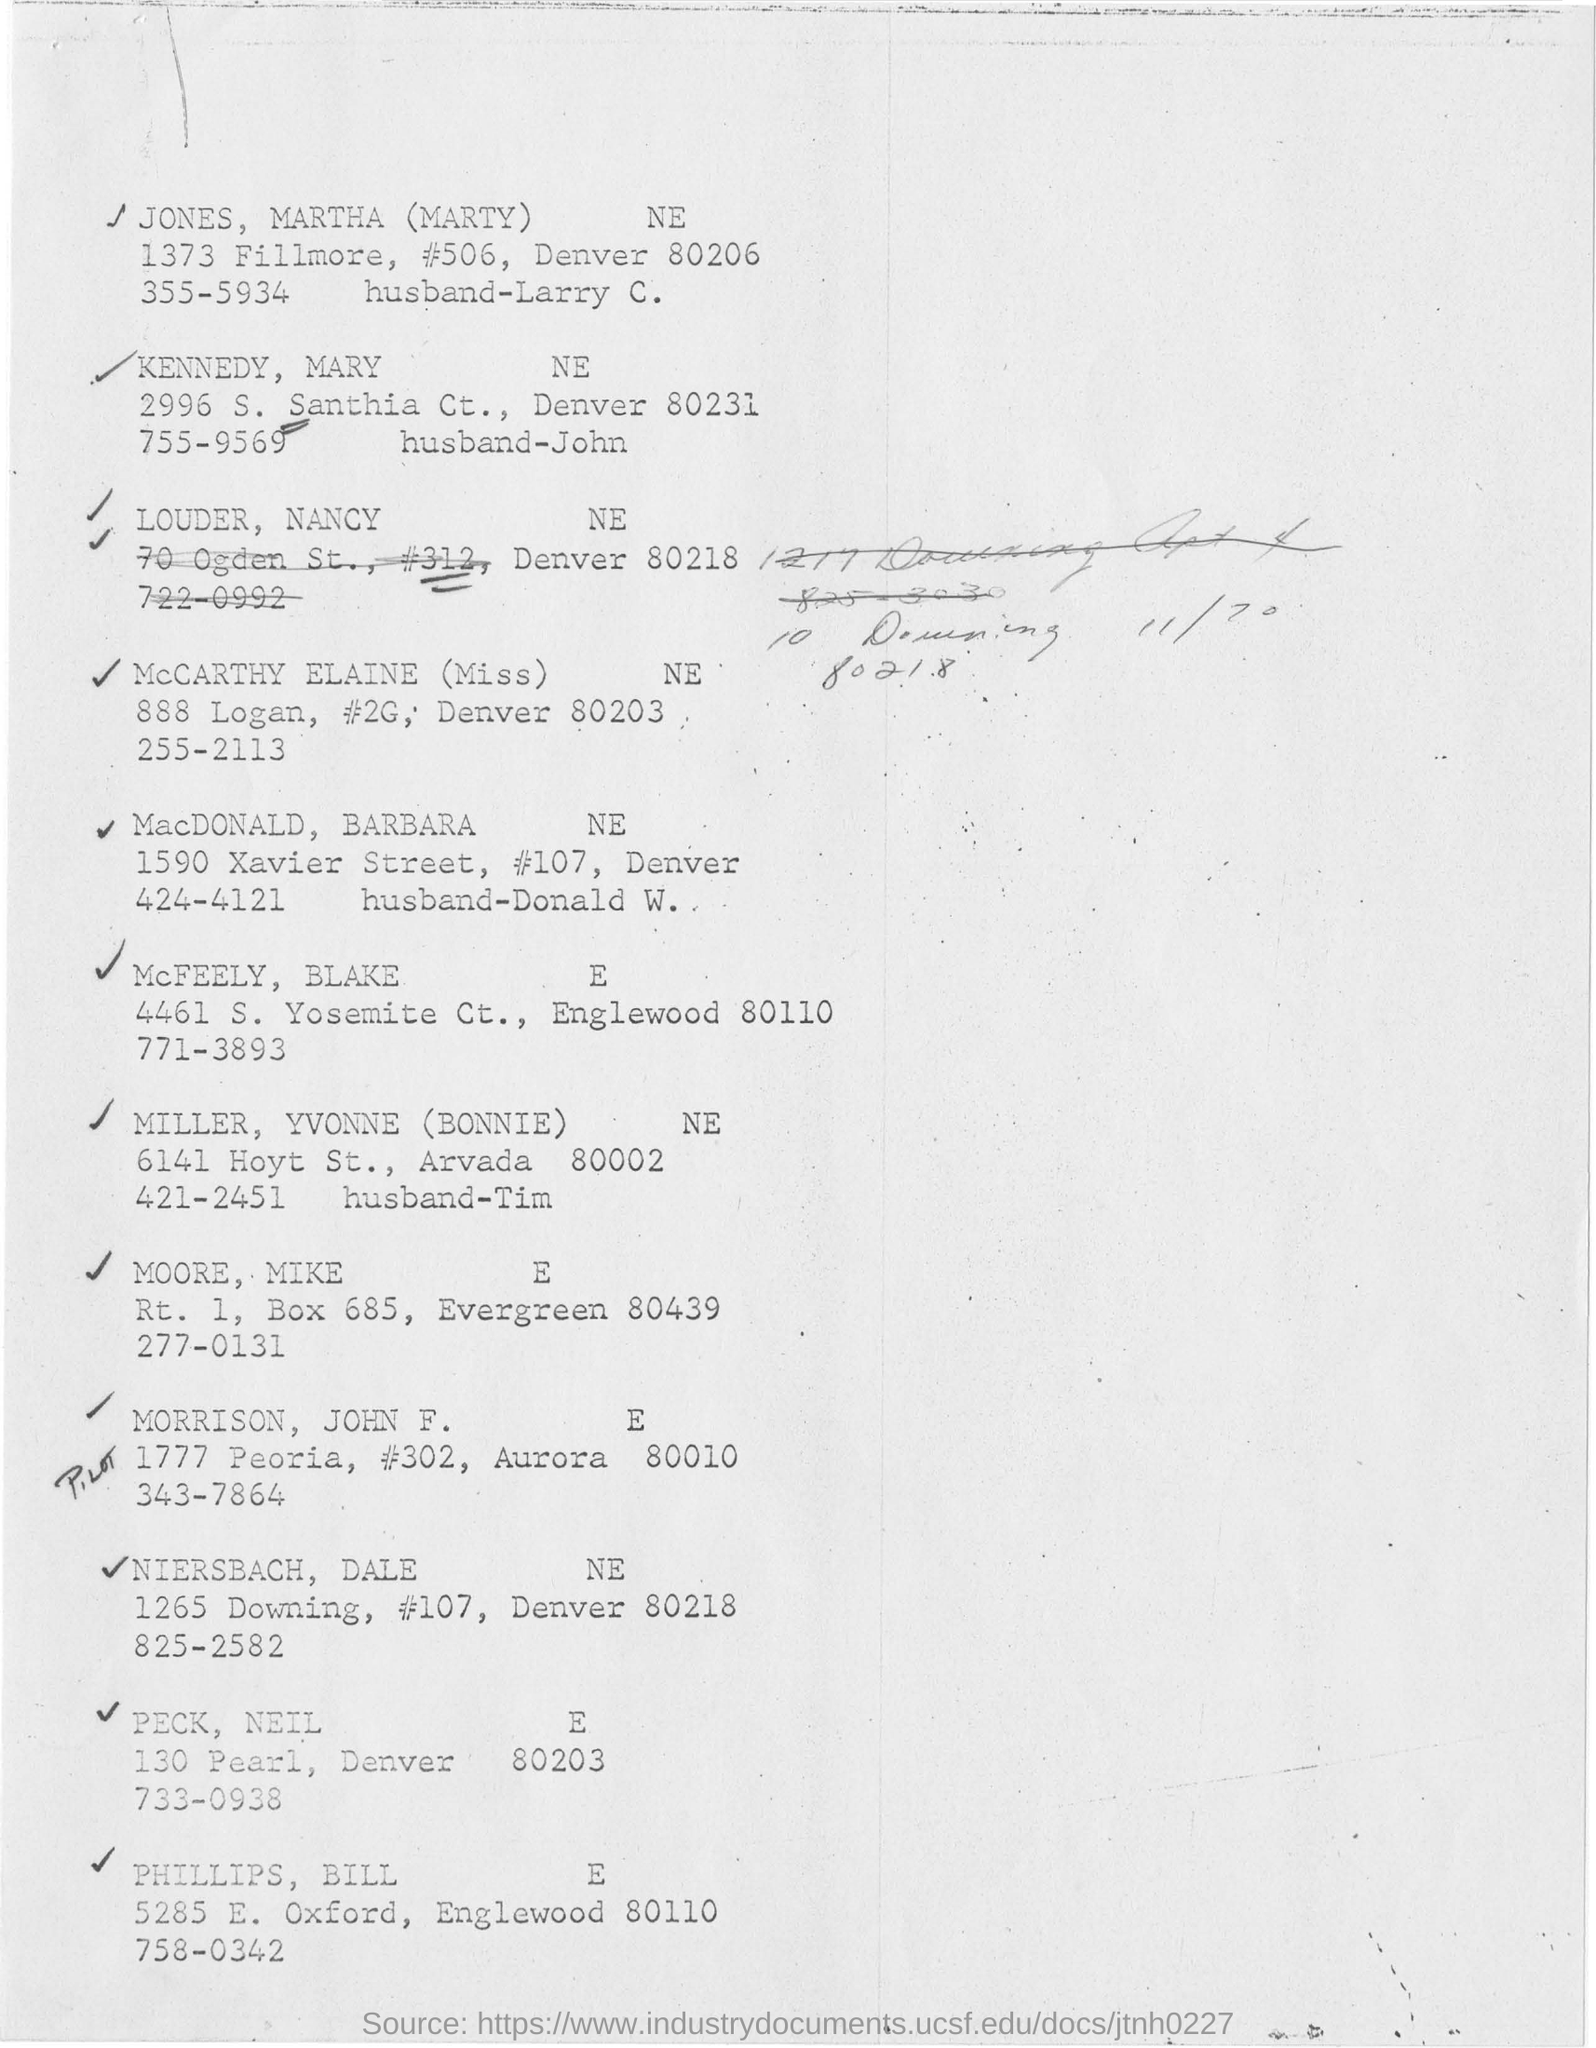Outline some significant characteristics in this image. The address of McCarthy Elaine is 888 Logan Street, unit 2G, Denver 80203. The name on the first line is "Jones, Martha. Santhia is located in Denver. 